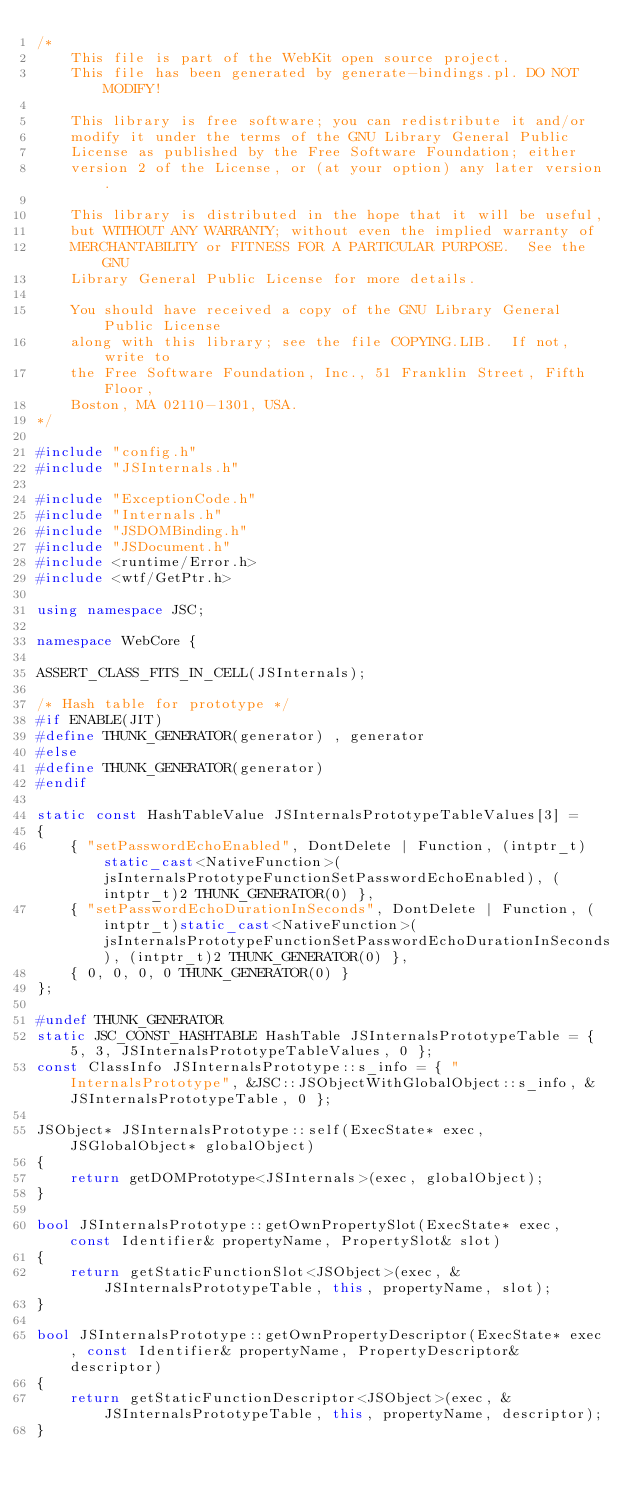Convert code to text. <code><loc_0><loc_0><loc_500><loc_500><_C++_>/*
    This file is part of the WebKit open source project.
    This file has been generated by generate-bindings.pl. DO NOT MODIFY!

    This library is free software; you can redistribute it and/or
    modify it under the terms of the GNU Library General Public
    License as published by the Free Software Foundation; either
    version 2 of the License, or (at your option) any later version.

    This library is distributed in the hope that it will be useful,
    but WITHOUT ANY WARRANTY; without even the implied warranty of
    MERCHANTABILITY or FITNESS FOR A PARTICULAR PURPOSE.  See the GNU
    Library General Public License for more details.

    You should have received a copy of the GNU Library General Public License
    along with this library; see the file COPYING.LIB.  If not, write to
    the Free Software Foundation, Inc., 51 Franklin Street, Fifth Floor,
    Boston, MA 02110-1301, USA.
*/

#include "config.h"
#include "JSInternals.h"

#include "ExceptionCode.h"
#include "Internals.h"
#include "JSDOMBinding.h"
#include "JSDocument.h"
#include <runtime/Error.h>
#include <wtf/GetPtr.h>

using namespace JSC;

namespace WebCore {

ASSERT_CLASS_FITS_IN_CELL(JSInternals);

/* Hash table for prototype */
#if ENABLE(JIT)
#define THUNK_GENERATOR(generator) , generator
#else
#define THUNK_GENERATOR(generator)
#endif

static const HashTableValue JSInternalsPrototypeTableValues[3] =
{
    { "setPasswordEchoEnabled", DontDelete | Function, (intptr_t)static_cast<NativeFunction>(jsInternalsPrototypeFunctionSetPasswordEchoEnabled), (intptr_t)2 THUNK_GENERATOR(0) },
    { "setPasswordEchoDurationInSeconds", DontDelete | Function, (intptr_t)static_cast<NativeFunction>(jsInternalsPrototypeFunctionSetPasswordEchoDurationInSeconds), (intptr_t)2 THUNK_GENERATOR(0) },
    { 0, 0, 0, 0 THUNK_GENERATOR(0) }
};

#undef THUNK_GENERATOR
static JSC_CONST_HASHTABLE HashTable JSInternalsPrototypeTable = { 5, 3, JSInternalsPrototypeTableValues, 0 };
const ClassInfo JSInternalsPrototype::s_info = { "InternalsPrototype", &JSC::JSObjectWithGlobalObject::s_info, &JSInternalsPrototypeTable, 0 };

JSObject* JSInternalsPrototype::self(ExecState* exec, JSGlobalObject* globalObject)
{
    return getDOMPrototype<JSInternals>(exec, globalObject);
}

bool JSInternalsPrototype::getOwnPropertySlot(ExecState* exec, const Identifier& propertyName, PropertySlot& slot)
{
    return getStaticFunctionSlot<JSObject>(exec, &JSInternalsPrototypeTable, this, propertyName, slot);
}

bool JSInternalsPrototype::getOwnPropertyDescriptor(ExecState* exec, const Identifier& propertyName, PropertyDescriptor& descriptor)
{
    return getStaticFunctionDescriptor<JSObject>(exec, &JSInternalsPrototypeTable, this, propertyName, descriptor);
}
</code> 